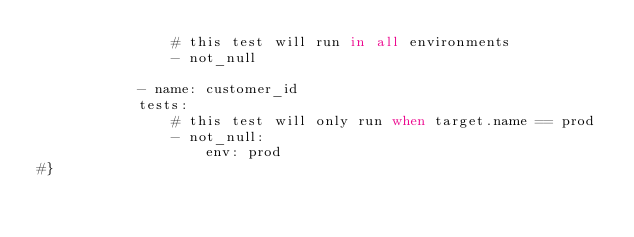Convert code to text. <code><loc_0><loc_0><loc_500><loc_500><_SQL_>                # this test will run in all environments
                - not_null

            - name: customer_id
            tests:
                # this test will only run when target.name == prod
                - not_null:
                    env: prod
#}
</code> 